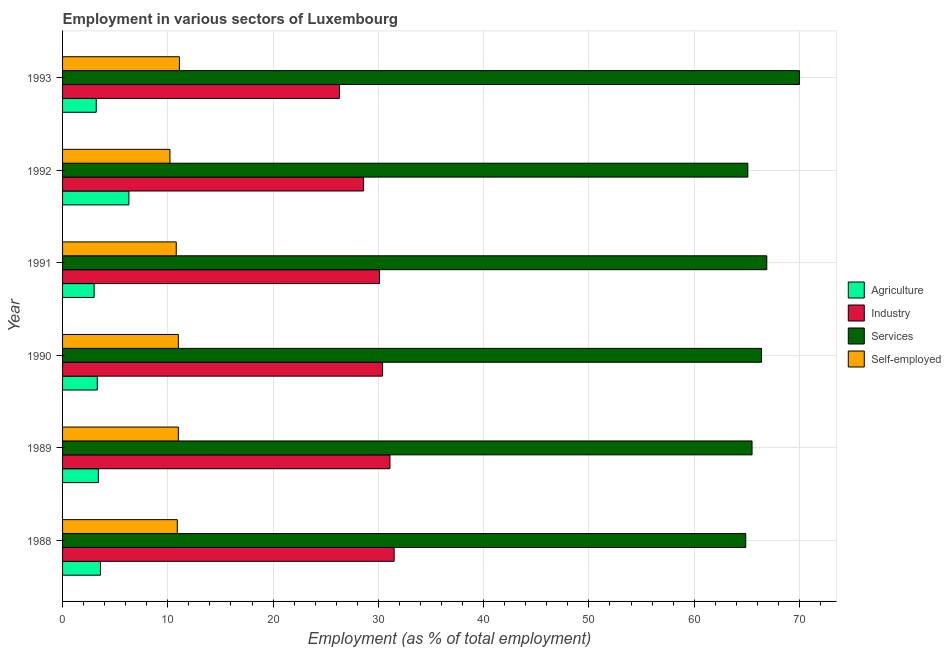How many different coloured bars are there?
Your answer should be very brief. 4. How many groups of bars are there?
Provide a succinct answer. 6. How many bars are there on the 6th tick from the top?
Make the answer very short. 4. In how many cases, is the number of bars for a given year not equal to the number of legend labels?
Keep it short and to the point. 0. What is the percentage of self employed workers in 1991?
Provide a short and direct response. 10.8. Across all years, what is the maximum percentage of self employed workers?
Your answer should be very brief. 11.1. Across all years, what is the minimum percentage of workers in industry?
Make the answer very short. 26.3. What is the total percentage of workers in agriculture in the graph?
Your response must be concise. 22.8. What is the difference between the percentage of workers in agriculture in 1993 and the percentage of self employed workers in 1991?
Provide a succinct answer. -7.6. What is the average percentage of workers in agriculture per year?
Give a very brief answer. 3.8. In the year 1988, what is the difference between the percentage of workers in services and percentage of self employed workers?
Keep it short and to the point. 54. In how many years, is the percentage of workers in agriculture greater than 44 %?
Your answer should be compact. 0. Is the percentage of workers in agriculture in 1991 less than that in 1993?
Give a very brief answer. Yes. Is the difference between the percentage of self employed workers in 1988 and 1990 greater than the difference between the percentage of workers in agriculture in 1988 and 1990?
Your answer should be compact. No. What is the difference between the highest and the lowest percentage of workers in industry?
Provide a succinct answer. 5.2. Is it the case that in every year, the sum of the percentage of workers in agriculture and percentage of self employed workers is greater than the sum of percentage of workers in services and percentage of workers in industry?
Ensure brevity in your answer.  Yes. What does the 1st bar from the top in 1991 represents?
Provide a short and direct response. Self-employed. What does the 1st bar from the bottom in 1993 represents?
Offer a terse response. Agriculture. Is it the case that in every year, the sum of the percentage of workers in agriculture and percentage of workers in industry is greater than the percentage of workers in services?
Your answer should be very brief. No. How many bars are there?
Ensure brevity in your answer.  24. Are all the bars in the graph horizontal?
Offer a very short reply. Yes. How many years are there in the graph?
Offer a terse response. 6. What is the difference between two consecutive major ticks on the X-axis?
Your answer should be very brief. 10. Where does the legend appear in the graph?
Provide a short and direct response. Center right. What is the title of the graph?
Provide a succinct answer. Employment in various sectors of Luxembourg. What is the label or title of the X-axis?
Ensure brevity in your answer.  Employment (as % of total employment). What is the label or title of the Y-axis?
Ensure brevity in your answer.  Year. What is the Employment (as % of total employment) of Agriculture in 1988?
Keep it short and to the point. 3.6. What is the Employment (as % of total employment) of Industry in 1988?
Ensure brevity in your answer.  31.5. What is the Employment (as % of total employment) of Services in 1988?
Give a very brief answer. 64.9. What is the Employment (as % of total employment) in Self-employed in 1988?
Your response must be concise. 10.9. What is the Employment (as % of total employment) in Agriculture in 1989?
Provide a short and direct response. 3.4. What is the Employment (as % of total employment) in Industry in 1989?
Give a very brief answer. 31.1. What is the Employment (as % of total employment) in Services in 1989?
Ensure brevity in your answer.  65.5. What is the Employment (as % of total employment) in Self-employed in 1989?
Keep it short and to the point. 11. What is the Employment (as % of total employment) of Agriculture in 1990?
Provide a succinct answer. 3.3. What is the Employment (as % of total employment) in Industry in 1990?
Offer a very short reply. 30.4. What is the Employment (as % of total employment) of Services in 1990?
Your answer should be very brief. 66.4. What is the Employment (as % of total employment) of Industry in 1991?
Offer a terse response. 30.1. What is the Employment (as % of total employment) in Services in 1991?
Provide a short and direct response. 66.9. What is the Employment (as % of total employment) of Self-employed in 1991?
Make the answer very short. 10.8. What is the Employment (as % of total employment) in Agriculture in 1992?
Your answer should be compact. 6.3. What is the Employment (as % of total employment) in Industry in 1992?
Keep it short and to the point. 28.6. What is the Employment (as % of total employment) in Services in 1992?
Your response must be concise. 65.1. What is the Employment (as % of total employment) of Self-employed in 1992?
Offer a very short reply. 10.2. What is the Employment (as % of total employment) in Agriculture in 1993?
Your response must be concise. 3.2. What is the Employment (as % of total employment) in Industry in 1993?
Make the answer very short. 26.3. What is the Employment (as % of total employment) of Services in 1993?
Your answer should be very brief. 70. What is the Employment (as % of total employment) of Self-employed in 1993?
Offer a very short reply. 11.1. Across all years, what is the maximum Employment (as % of total employment) of Agriculture?
Provide a short and direct response. 6.3. Across all years, what is the maximum Employment (as % of total employment) of Industry?
Ensure brevity in your answer.  31.5. Across all years, what is the maximum Employment (as % of total employment) of Services?
Provide a succinct answer. 70. Across all years, what is the maximum Employment (as % of total employment) in Self-employed?
Give a very brief answer. 11.1. Across all years, what is the minimum Employment (as % of total employment) in Industry?
Provide a short and direct response. 26.3. Across all years, what is the minimum Employment (as % of total employment) in Services?
Your answer should be very brief. 64.9. Across all years, what is the minimum Employment (as % of total employment) in Self-employed?
Make the answer very short. 10.2. What is the total Employment (as % of total employment) of Agriculture in the graph?
Give a very brief answer. 22.8. What is the total Employment (as % of total employment) in Industry in the graph?
Offer a terse response. 178. What is the total Employment (as % of total employment) of Services in the graph?
Make the answer very short. 398.8. What is the difference between the Employment (as % of total employment) in Industry in 1988 and that in 1989?
Offer a terse response. 0.4. What is the difference between the Employment (as % of total employment) of Services in 1988 and that in 1989?
Your response must be concise. -0.6. What is the difference between the Employment (as % of total employment) of Agriculture in 1988 and that in 1990?
Keep it short and to the point. 0.3. What is the difference between the Employment (as % of total employment) of Industry in 1988 and that in 1990?
Provide a short and direct response. 1.1. What is the difference between the Employment (as % of total employment) of Services in 1988 and that in 1990?
Ensure brevity in your answer.  -1.5. What is the difference between the Employment (as % of total employment) in Self-employed in 1988 and that in 1990?
Ensure brevity in your answer.  -0.1. What is the difference between the Employment (as % of total employment) in Agriculture in 1988 and that in 1991?
Offer a very short reply. 0.6. What is the difference between the Employment (as % of total employment) of Agriculture in 1988 and that in 1992?
Your answer should be compact. -2.7. What is the difference between the Employment (as % of total employment) in Industry in 1988 and that in 1992?
Make the answer very short. 2.9. What is the difference between the Employment (as % of total employment) of Agriculture in 1988 and that in 1993?
Provide a succinct answer. 0.4. What is the difference between the Employment (as % of total employment) in Industry in 1989 and that in 1990?
Offer a very short reply. 0.7. What is the difference between the Employment (as % of total employment) in Services in 1989 and that in 1990?
Provide a succinct answer. -0.9. What is the difference between the Employment (as % of total employment) in Agriculture in 1989 and that in 1991?
Make the answer very short. 0.4. What is the difference between the Employment (as % of total employment) of Agriculture in 1989 and that in 1992?
Ensure brevity in your answer.  -2.9. What is the difference between the Employment (as % of total employment) of Industry in 1989 and that in 1992?
Make the answer very short. 2.5. What is the difference between the Employment (as % of total employment) in Services in 1989 and that in 1992?
Ensure brevity in your answer.  0.4. What is the difference between the Employment (as % of total employment) of Self-employed in 1989 and that in 1992?
Offer a very short reply. 0.8. What is the difference between the Employment (as % of total employment) in Agriculture in 1990 and that in 1991?
Provide a short and direct response. 0.3. What is the difference between the Employment (as % of total employment) of Industry in 1990 and that in 1991?
Your response must be concise. 0.3. What is the difference between the Employment (as % of total employment) of Agriculture in 1990 and that in 1992?
Provide a succinct answer. -3. What is the difference between the Employment (as % of total employment) of Industry in 1990 and that in 1992?
Ensure brevity in your answer.  1.8. What is the difference between the Employment (as % of total employment) of Self-employed in 1990 and that in 1992?
Your answer should be very brief. 0.8. What is the difference between the Employment (as % of total employment) in Agriculture in 1990 and that in 1993?
Provide a short and direct response. 0.1. What is the difference between the Employment (as % of total employment) in Industry in 1990 and that in 1993?
Ensure brevity in your answer.  4.1. What is the difference between the Employment (as % of total employment) of Services in 1990 and that in 1993?
Offer a terse response. -3.6. What is the difference between the Employment (as % of total employment) of Self-employed in 1990 and that in 1993?
Offer a very short reply. -0.1. What is the difference between the Employment (as % of total employment) in Industry in 1991 and that in 1992?
Keep it short and to the point. 1.5. What is the difference between the Employment (as % of total employment) in Services in 1991 and that in 1992?
Your response must be concise. 1.8. What is the difference between the Employment (as % of total employment) of Self-employed in 1991 and that in 1993?
Ensure brevity in your answer.  -0.3. What is the difference between the Employment (as % of total employment) in Services in 1992 and that in 1993?
Offer a very short reply. -4.9. What is the difference between the Employment (as % of total employment) in Agriculture in 1988 and the Employment (as % of total employment) in Industry in 1989?
Your response must be concise. -27.5. What is the difference between the Employment (as % of total employment) in Agriculture in 1988 and the Employment (as % of total employment) in Services in 1989?
Provide a succinct answer. -61.9. What is the difference between the Employment (as % of total employment) of Industry in 1988 and the Employment (as % of total employment) of Services in 1989?
Ensure brevity in your answer.  -34. What is the difference between the Employment (as % of total employment) of Services in 1988 and the Employment (as % of total employment) of Self-employed in 1989?
Offer a very short reply. 53.9. What is the difference between the Employment (as % of total employment) of Agriculture in 1988 and the Employment (as % of total employment) of Industry in 1990?
Provide a short and direct response. -26.8. What is the difference between the Employment (as % of total employment) in Agriculture in 1988 and the Employment (as % of total employment) in Services in 1990?
Provide a succinct answer. -62.8. What is the difference between the Employment (as % of total employment) of Agriculture in 1988 and the Employment (as % of total employment) of Self-employed in 1990?
Offer a very short reply. -7.4. What is the difference between the Employment (as % of total employment) of Industry in 1988 and the Employment (as % of total employment) of Services in 1990?
Ensure brevity in your answer.  -34.9. What is the difference between the Employment (as % of total employment) of Industry in 1988 and the Employment (as % of total employment) of Self-employed in 1990?
Your response must be concise. 20.5. What is the difference between the Employment (as % of total employment) in Services in 1988 and the Employment (as % of total employment) in Self-employed in 1990?
Offer a terse response. 53.9. What is the difference between the Employment (as % of total employment) in Agriculture in 1988 and the Employment (as % of total employment) in Industry in 1991?
Your answer should be compact. -26.5. What is the difference between the Employment (as % of total employment) of Agriculture in 1988 and the Employment (as % of total employment) of Services in 1991?
Offer a very short reply. -63.3. What is the difference between the Employment (as % of total employment) in Industry in 1988 and the Employment (as % of total employment) in Services in 1991?
Make the answer very short. -35.4. What is the difference between the Employment (as % of total employment) in Industry in 1988 and the Employment (as % of total employment) in Self-employed in 1991?
Offer a terse response. 20.7. What is the difference between the Employment (as % of total employment) in Services in 1988 and the Employment (as % of total employment) in Self-employed in 1991?
Make the answer very short. 54.1. What is the difference between the Employment (as % of total employment) in Agriculture in 1988 and the Employment (as % of total employment) in Industry in 1992?
Your answer should be compact. -25. What is the difference between the Employment (as % of total employment) in Agriculture in 1988 and the Employment (as % of total employment) in Services in 1992?
Provide a succinct answer. -61.5. What is the difference between the Employment (as % of total employment) in Industry in 1988 and the Employment (as % of total employment) in Services in 1992?
Provide a short and direct response. -33.6. What is the difference between the Employment (as % of total employment) of Industry in 1988 and the Employment (as % of total employment) of Self-employed in 1992?
Give a very brief answer. 21.3. What is the difference between the Employment (as % of total employment) of Services in 1988 and the Employment (as % of total employment) of Self-employed in 1992?
Offer a very short reply. 54.7. What is the difference between the Employment (as % of total employment) in Agriculture in 1988 and the Employment (as % of total employment) in Industry in 1993?
Your answer should be compact. -22.7. What is the difference between the Employment (as % of total employment) in Agriculture in 1988 and the Employment (as % of total employment) in Services in 1993?
Give a very brief answer. -66.4. What is the difference between the Employment (as % of total employment) in Industry in 1988 and the Employment (as % of total employment) in Services in 1993?
Your response must be concise. -38.5. What is the difference between the Employment (as % of total employment) in Industry in 1988 and the Employment (as % of total employment) in Self-employed in 1993?
Your answer should be compact. 20.4. What is the difference between the Employment (as % of total employment) in Services in 1988 and the Employment (as % of total employment) in Self-employed in 1993?
Your answer should be compact. 53.8. What is the difference between the Employment (as % of total employment) of Agriculture in 1989 and the Employment (as % of total employment) of Industry in 1990?
Provide a short and direct response. -27. What is the difference between the Employment (as % of total employment) in Agriculture in 1989 and the Employment (as % of total employment) in Services in 1990?
Your answer should be very brief. -63. What is the difference between the Employment (as % of total employment) of Industry in 1989 and the Employment (as % of total employment) of Services in 1990?
Provide a succinct answer. -35.3. What is the difference between the Employment (as % of total employment) in Industry in 1989 and the Employment (as % of total employment) in Self-employed in 1990?
Keep it short and to the point. 20.1. What is the difference between the Employment (as % of total employment) of Services in 1989 and the Employment (as % of total employment) of Self-employed in 1990?
Your answer should be compact. 54.5. What is the difference between the Employment (as % of total employment) in Agriculture in 1989 and the Employment (as % of total employment) in Industry in 1991?
Ensure brevity in your answer.  -26.7. What is the difference between the Employment (as % of total employment) in Agriculture in 1989 and the Employment (as % of total employment) in Services in 1991?
Provide a short and direct response. -63.5. What is the difference between the Employment (as % of total employment) of Agriculture in 1989 and the Employment (as % of total employment) of Self-employed in 1991?
Your response must be concise. -7.4. What is the difference between the Employment (as % of total employment) of Industry in 1989 and the Employment (as % of total employment) of Services in 1991?
Your answer should be compact. -35.8. What is the difference between the Employment (as % of total employment) of Industry in 1989 and the Employment (as % of total employment) of Self-employed in 1991?
Offer a terse response. 20.3. What is the difference between the Employment (as % of total employment) of Services in 1989 and the Employment (as % of total employment) of Self-employed in 1991?
Make the answer very short. 54.7. What is the difference between the Employment (as % of total employment) of Agriculture in 1989 and the Employment (as % of total employment) of Industry in 1992?
Your response must be concise. -25.2. What is the difference between the Employment (as % of total employment) of Agriculture in 1989 and the Employment (as % of total employment) of Services in 1992?
Ensure brevity in your answer.  -61.7. What is the difference between the Employment (as % of total employment) in Agriculture in 1989 and the Employment (as % of total employment) in Self-employed in 1992?
Provide a succinct answer. -6.8. What is the difference between the Employment (as % of total employment) of Industry in 1989 and the Employment (as % of total employment) of Services in 1992?
Provide a short and direct response. -34. What is the difference between the Employment (as % of total employment) of Industry in 1989 and the Employment (as % of total employment) of Self-employed in 1992?
Your answer should be very brief. 20.9. What is the difference between the Employment (as % of total employment) in Services in 1989 and the Employment (as % of total employment) in Self-employed in 1992?
Provide a succinct answer. 55.3. What is the difference between the Employment (as % of total employment) of Agriculture in 1989 and the Employment (as % of total employment) of Industry in 1993?
Your answer should be very brief. -22.9. What is the difference between the Employment (as % of total employment) of Agriculture in 1989 and the Employment (as % of total employment) of Services in 1993?
Keep it short and to the point. -66.6. What is the difference between the Employment (as % of total employment) of Agriculture in 1989 and the Employment (as % of total employment) of Self-employed in 1993?
Your answer should be compact. -7.7. What is the difference between the Employment (as % of total employment) in Industry in 1989 and the Employment (as % of total employment) in Services in 1993?
Provide a succinct answer. -38.9. What is the difference between the Employment (as % of total employment) in Services in 1989 and the Employment (as % of total employment) in Self-employed in 1993?
Your answer should be compact. 54.4. What is the difference between the Employment (as % of total employment) of Agriculture in 1990 and the Employment (as % of total employment) of Industry in 1991?
Make the answer very short. -26.8. What is the difference between the Employment (as % of total employment) in Agriculture in 1990 and the Employment (as % of total employment) in Services in 1991?
Provide a short and direct response. -63.6. What is the difference between the Employment (as % of total employment) in Industry in 1990 and the Employment (as % of total employment) in Services in 1991?
Your answer should be very brief. -36.5. What is the difference between the Employment (as % of total employment) of Industry in 1990 and the Employment (as % of total employment) of Self-employed in 1991?
Your answer should be compact. 19.6. What is the difference between the Employment (as % of total employment) in Services in 1990 and the Employment (as % of total employment) in Self-employed in 1991?
Provide a short and direct response. 55.6. What is the difference between the Employment (as % of total employment) of Agriculture in 1990 and the Employment (as % of total employment) of Industry in 1992?
Give a very brief answer. -25.3. What is the difference between the Employment (as % of total employment) of Agriculture in 1990 and the Employment (as % of total employment) of Services in 1992?
Make the answer very short. -61.8. What is the difference between the Employment (as % of total employment) in Agriculture in 1990 and the Employment (as % of total employment) in Self-employed in 1992?
Your answer should be compact. -6.9. What is the difference between the Employment (as % of total employment) of Industry in 1990 and the Employment (as % of total employment) of Services in 1992?
Provide a succinct answer. -34.7. What is the difference between the Employment (as % of total employment) in Industry in 1990 and the Employment (as % of total employment) in Self-employed in 1992?
Keep it short and to the point. 20.2. What is the difference between the Employment (as % of total employment) in Services in 1990 and the Employment (as % of total employment) in Self-employed in 1992?
Offer a very short reply. 56.2. What is the difference between the Employment (as % of total employment) in Agriculture in 1990 and the Employment (as % of total employment) in Industry in 1993?
Ensure brevity in your answer.  -23. What is the difference between the Employment (as % of total employment) of Agriculture in 1990 and the Employment (as % of total employment) of Services in 1993?
Your response must be concise. -66.7. What is the difference between the Employment (as % of total employment) in Industry in 1990 and the Employment (as % of total employment) in Services in 1993?
Your answer should be very brief. -39.6. What is the difference between the Employment (as % of total employment) of Industry in 1990 and the Employment (as % of total employment) of Self-employed in 1993?
Provide a short and direct response. 19.3. What is the difference between the Employment (as % of total employment) of Services in 1990 and the Employment (as % of total employment) of Self-employed in 1993?
Make the answer very short. 55.3. What is the difference between the Employment (as % of total employment) of Agriculture in 1991 and the Employment (as % of total employment) of Industry in 1992?
Provide a succinct answer. -25.6. What is the difference between the Employment (as % of total employment) in Agriculture in 1991 and the Employment (as % of total employment) in Services in 1992?
Give a very brief answer. -62.1. What is the difference between the Employment (as % of total employment) of Industry in 1991 and the Employment (as % of total employment) of Services in 1992?
Provide a succinct answer. -35. What is the difference between the Employment (as % of total employment) in Industry in 1991 and the Employment (as % of total employment) in Self-employed in 1992?
Provide a short and direct response. 19.9. What is the difference between the Employment (as % of total employment) of Services in 1991 and the Employment (as % of total employment) of Self-employed in 1992?
Provide a short and direct response. 56.7. What is the difference between the Employment (as % of total employment) of Agriculture in 1991 and the Employment (as % of total employment) of Industry in 1993?
Your response must be concise. -23.3. What is the difference between the Employment (as % of total employment) in Agriculture in 1991 and the Employment (as % of total employment) in Services in 1993?
Your answer should be compact. -67. What is the difference between the Employment (as % of total employment) of Industry in 1991 and the Employment (as % of total employment) of Services in 1993?
Provide a short and direct response. -39.9. What is the difference between the Employment (as % of total employment) in Services in 1991 and the Employment (as % of total employment) in Self-employed in 1993?
Your response must be concise. 55.8. What is the difference between the Employment (as % of total employment) in Agriculture in 1992 and the Employment (as % of total employment) in Services in 1993?
Ensure brevity in your answer.  -63.7. What is the difference between the Employment (as % of total employment) of Industry in 1992 and the Employment (as % of total employment) of Services in 1993?
Make the answer very short. -41.4. What is the difference between the Employment (as % of total employment) of Industry in 1992 and the Employment (as % of total employment) of Self-employed in 1993?
Offer a very short reply. 17.5. What is the average Employment (as % of total employment) in Industry per year?
Offer a very short reply. 29.67. What is the average Employment (as % of total employment) of Services per year?
Provide a succinct answer. 66.47. What is the average Employment (as % of total employment) in Self-employed per year?
Offer a very short reply. 10.83. In the year 1988, what is the difference between the Employment (as % of total employment) in Agriculture and Employment (as % of total employment) in Industry?
Your answer should be very brief. -27.9. In the year 1988, what is the difference between the Employment (as % of total employment) of Agriculture and Employment (as % of total employment) of Services?
Offer a very short reply. -61.3. In the year 1988, what is the difference between the Employment (as % of total employment) of Agriculture and Employment (as % of total employment) of Self-employed?
Make the answer very short. -7.3. In the year 1988, what is the difference between the Employment (as % of total employment) in Industry and Employment (as % of total employment) in Services?
Make the answer very short. -33.4. In the year 1988, what is the difference between the Employment (as % of total employment) of Industry and Employment (as % of total employment) of Self-employed?
Provide a succinct answer. 20.6. In the year 1989, what is the difference between the Employment (as % of total employment) of Agriculture and Employment (as % of total employment) of Industry?
Your response must be concise. -27.7. In the year 1989, what is the difference between the Employment (as % of total employment) of Agriculture and Employment (as % of total employment) of Services?
Provide a succinct answer. -62.1. In the year 1989, what is the difference between the Employment (as % of total employment) of Agriculture and Employment (as % of total employment) of Self-employed?
Offer a very short reply. -7.6. In the year 1989, what is the difference between the Employment (as % of total employment) of Industry and Employment (as % of total employment) of Services?
Ensure brevity in your answer.  -34.4. In the year 1989, what is the difference between the Employment (as % of total employment) of Industry and Employment (as % of total employment) of Self-employed?
Provide a succinct answer. 20.1. In the year 1989, what is the difference between the Employment (as % of total employment) in Services and Employment (as % of total employment) in Self-employed?
Offer a very short reply. 54.5. In the year 1990, what is the difference between the Employment (as % of total employment) of Agriculture and Employment (as % of total employment) of Industry?
Ensure brevity in your answer.  -27.1. In the year 1990, what is the difference between the Employment (as % of total employment) in Agriculture and Employment (as % of total employment) in Services?
Make the answer very short. -63.1. In the year 1990, what is the difference between the Employment (as % of total employment) of Agriculture and Employment (as % of total employment) of Self-employed?
Ensure brevity in your answer.  -7.7. In the year 1990, what is the difference between the Employment (as % of total employment) in Industry and Employment (as % of total employment) in Services?
Provide a short and direct response. -36. In the year 1990, what is the difference between the Employment (as % of total employment) of Services and Employment (as % of total employment) of Self-employed?
Keep it short and to the point. 55.4. In the year 1991, what is the difference between the Employment (as % of total employment) of Agriculture and Employment (as % of total employment) of Industry?
Make the answer very short. -27.1. In the year 1991, what is the difference between the Employment (as % of total employment) of Agriculture and Employment (as % of total employment) of Services?
Offer a very short reply. -63.9. In the year 1991, what is the difference between the Employment (as % of total employment) of Industry and Employment (as % of total employment) of Services?
Your answer should be compact. -36.8. In the year 1991, what is the difference between the Employment (as % of total employment) of Industry and Employment (as % of total employment) of Self-employed?
Make the answer very short. 19.3. In the year 1991, what is the difference between the Employment (as % of total employment) in Services and Employment (as % of total employment) in Self-employed?
Offer a terse response. 56.1. In the year 1992, what is the difference between the Employment (as % of total employment) in Agriculture and Employment (as % of total employment) in Industry?
Give a very brief answer. -22.3. In the year 1992, what is the difference between the Employment (as % of total employment) in Agriculture and Employment (as % of total employment) in Services?
Offer a terse response. -58.8. In the year 1992, what is the difference between the Employment (as % of total employment) in Industry and Employment (as % of total employment) in Services?
Ensure brevity in your answer.  -36.5. In the year 1992, what is the difference between the Employment (as % of total employment) in Industry and Employment (as % of total employment) in Self-employed?
Offer a terse response. 18.4. In the year 1992, what is the difference between the Employment (as % of total employment) in Services and Employment (as % of total employment) in Self-employed?
Ensure brevity in your answer.  54.9. In the year 1993, what is the difference between the Employment (as % of total employment) of Agriculture and Employment (as % of total employment) of Industry?
Offer a very short reply. -23.1. In the year 1993, what is the difference between the Employment (as % of total employment) in Agriculture and Employment (as % of total employment) in Services?
Offer a terse response. -66.8. In the year 1993, what is the difference between the Employment (as % of total employment) of Agriculture and Employment (as % of total employment) of Self-employed?
Your answer should be compact. -7.9. In the year 1993, what is the difference between the Employment (as % of total employment) in Industry and Employment (as % of total employment) in Services?
Provide a short and direct response. -43.7. In the year 1993, what is the difference between the Employment (as % of total employment) in Services and Employment (as % of total employment) in Self-employed?
Provide a succinct answer. 58.9. What is the ratio of the Employment (as % of total employment) in Agriculture in 1988 to that in 1989?
Provide a short and direct response. 1.06. What is the ratio of the Employment (as % of total employment) of Industry in 1988 to that in 1989?
Ensure brevity in your answer.  1.01. What is the ratio of the Employment (as % of total employment) in Services in 1988 to that in 1989?
Give a very brief answer. 0.99. What is the ratio of the Employment (as % of total employment) in Self-employed in 1988 to that in 1989?
Your answer should be compact. 0.99. What is the ratio of the Employment (as % of total employment) in Agriculture in 1988 to that in 1990?
Give a very brief answer. 1.09. What is the ratio of the Employment (as % of total employment) of Industry in 1988 to that in 1990?
Your response must be concise. 1.04. What is the ratio of the Employment (as % of total employment) in Services in 1988 to that in 1990?
Provide a succinct answer. 0.98. What is the ratio of the Employment (as % of total employment) in Self-employed in 1988 to that in 1990?
Offer a very short reply. 0.99. What is the ratio of the Employment (as % of total employment) of Industry in 1988 to that in 1991?
Offer a terse response. 1.05. What is the ratio of the Employment (as % of total employment) in Services in 1988 to that in 1991?
Provide a succinct answer. 0.97. What is the ratio of the Employment (as % of total employment) of Self-employed in 1988 to that in 1991?
Offer a terse response. 1.01. What is the ratio of the Employment (as % of total employment) in Agriculture in 1988 to that in 1992?
Provide a short and direct response. 0.57. What is the ratio of the Employment (as % of total employment) in Industry in 1988 to that in 1992?
Your response must be concise. 1.1. What is the ratio of the Employment (as % of total employment) in Services in 1988 to that in 1992?
Your answer should be very brief. 1. What is the ratio of the Employment (as % of total employment) in Self-employed in 1988 to that in 1992?
Your answer should be compact. 1.07. What is the ratio of the Employment (as % of total employment) in Industry in 1988 to that in 1993?
Give a very brief answer. 1.2. What is the ratio of the Employment (as % of total employment) in Services in 1988 to that in 1993?
Ensure brevity in your answer.  0.93. What is the ratio of the Employment (as % of total employment) of Agriculture in 1989 to that in 1990?
Provide a short and direct response. 1.03. What is the ratio of the Employment (as % of total employment) in Services in 1989 to that in 1990?
Your answer should be compact. 0.99. What is the ratio of the Employment (as % of total employment) in Self-employed in 1989 to that in 1990?
Ensure brevity in your answer.  1. What is the ratio of the Employment (as % of total employment) of Agriculture in 1989 to that in 1991?
Your response must be concise. 1.13. What is the ratio of the Employment (as % of total employment) of Industry in 1989 to that in 1991?
Keep it short and to the point. 1.03. What is the ratio of the Employment (as % of total employment) of Services in 1989 to that in 1991?
Make the answer very short. 0.98. What is the ratio of the Employment (as % of total employment) of Self-employed in 1989 to that in 1991?
Your answer should be very brief. 1.02. What is the ratio of the Employment (as % of total employment) in Agriculture in 1989 to that in 1992?
Your answer should be very brief. 0.54. What is the ratio of the Employment (as % of total employment) of Industry in 1989 to that in 1992?
Make the answer very short. 1.09. What is the ratio of the Employment (as % of total employment) in Services in 1989 to that in 1992?
Keep it short and to the point. 1.01. What is the ratio of the Employment (as % of total employment) in Self-employed in 1989 to that in 1992?
Offer a terse response. 1.08. What is the ratio of the Employment (as % of total employment) of Agriculture in 1989 to that in 1993?
Give a very brief answer. 1.06. What is the ratio of the Employment (as % of total employment) in Industry in 1989 to that in 1993?
Offer a terse response. 1.18. What is the ratio of the Employment (as % of total employment) in Services in 1989 to that in 1993?
Give a very brief answer. 0.94. What is the ratio of the Employment (as % of total employment) of Self-employed in 1989 to that in 1993?
Your response must be concise. 0.99. What is the ratio of the Employment (as % of total employment) in Self-employed in 1990 to that in 1991?
Provide a succinct answer. 1.02. What is the ratio of the Employment (as % of total employment) in Agriculture in 1990 to that in 1992?
Your answer should be very brief. 0.52. What is the ratio of the Employment (as % of total employment) of Industry in 1990 to that in 1992?
Make the answer very short. 1.06. What is the ratio of the Employment (as % of total employment) of Self-employed in 1990 to that in 1992?
Give a very brief answer. 1.08. What is the ratio of the Employment (as % of total employment) in Agriculture in 1990 to that in 1993?
Keep it short and to the point. 1.03. What is the ratio of the Employment (as % of total employment) of Industry in 1990 to that in 1993?
Ensure brevity in your answer.  1.16. What is the ratio of the Employment (as % of total employment) in Services in 1990 to that in 1993?
Your response must be concise. 0.95. What is the ratio of the Employment (as % of total employment) in Agriculture in 1991 to that in 1992?
Provide a succinct answer. 0.48. What is the ratio of the Employment (as % of total employment) of Industry in 1991 to that in 1992?
Your response must be concise. 1.05. What is the ratio of the Employment (as % of total employment) of Services in 1991 to that in 1992?
Offer a very short reply. 1.03. What is the ratio of the Employment (as % of total employment) in Self-employed in 1991 to that in 1992?
Offer a terse response. 1.06. What is the ratio of the Employment (as % of total employment) of Agriculture in 1991 to that in 1993?
Provide a short and direct response. 0.94. What is the ratio of the Employment (as % of total employment) in Industry in 1991 to that in 1993?
Make the answer very short. 1.14. What is the ratio of the Employment (as % of total employment) in Services in 1991 to that in 1993?
Your answer should be very brief. 0.96. What is the ratio of the Employment (as % of total employment) of Agriculture in 1992 to that in 1993?
Your answer should be compact. 1.97. What is the ratio of the Employment (as % of total employment) of Industry in 1992 to that in 1993?
Provide a succinct answer. 1.09. What is the ratio of the Employment (as % of total employment) in Self-employed in 1992 to that in 1993?
Provide a succinct answer. 0.92. What is the difference between the highest and the lowest Employment (as % of total employment) of Services?
Your response must be concise. 5.1. What is the difference between the highest and the lowest Employment (as % of total employment) of Self-employed?
Give a very brief answer. 0.9. 